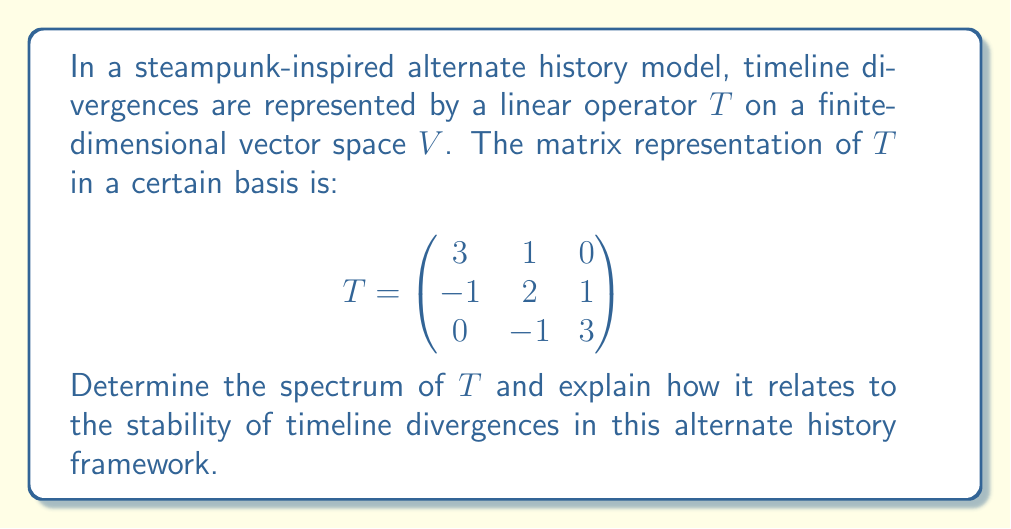Could you help me with this problem? To find the spectrum of the linear operator $T$, we need to determine its eigenvalues.

Step 1: Set up the characteristic equation
$$\det(T - \lambda I) = 0$$

where $\lambda$ represents the eigenvalues and $I$ is the 3x3 identity matrix.

Step 2: Expand the determinant
$$\begin{vmatrix}
3-\lambda & 1 & 0 \\
-1 & 2-\lambda & 1 \\
0 & -1 & 3-\lambda
\end{vmatrix} = 0$$

Step 3: Calculate the determinant
$$(3-\lambda)[(2-\lambda)(3-\lambda) - (-1)(1)] - 1[(-1)(3-\lambda) - 0] = 0$$
$$(3-\lambda)[(6-5\lambda+\lambda^2) + 1] + (3-\lambda) = 0$$
$$(3-\lambda)(7-5\lambda+\lambda^2) + (3-\lambda) = 0$$

Step 4: Simplify the equation
$$21 - 15\lambda + 3\lambda^2 - 7\lambda + 5\lambda^2 - \lambda^3 + 3 - \lambda = 0$$
$$-\lambda^3 + 8\lambda^2 - 23\lambda + 24 = 0$$

Step 5: Factor the equation
$$(\lambda - 2)(\lambda - 3)(\lambda - 4) = 0$$

The eigenvalues (spectrum) of $T$ are $\lambda_1 = 2$, $\lambda_2 = 3$, and $\lambda_3 = 4$.

In the context of alternate history and timeline divergences:
1. Each eigenvalue represents a distinct "divergence mode" in the timeline.
2. The magnitude of each eigenvalue indicates the rate at which that particular divergence grows or decays over time.
3. Since all eigenvalues are positive and real, all divergence modes are stable and grow exponentially.
4. The largest eigenvalue (4) represents the dominant divergence mode, which will become the most prominent over time.
5. The separation between eigenvalues (2, 3, and 4) suggests that the timeline divergences will become increasingly distinct as time progresses.
Answer: Spectrum of $T$: $\{2, 3, 4\}$ 